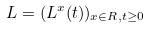<formula> <loc_0><loc_0><loc_500><loc_500>L = ( L ^ { x } ( t ) ) _ { x \in R , t \geq 0 }</formula> 